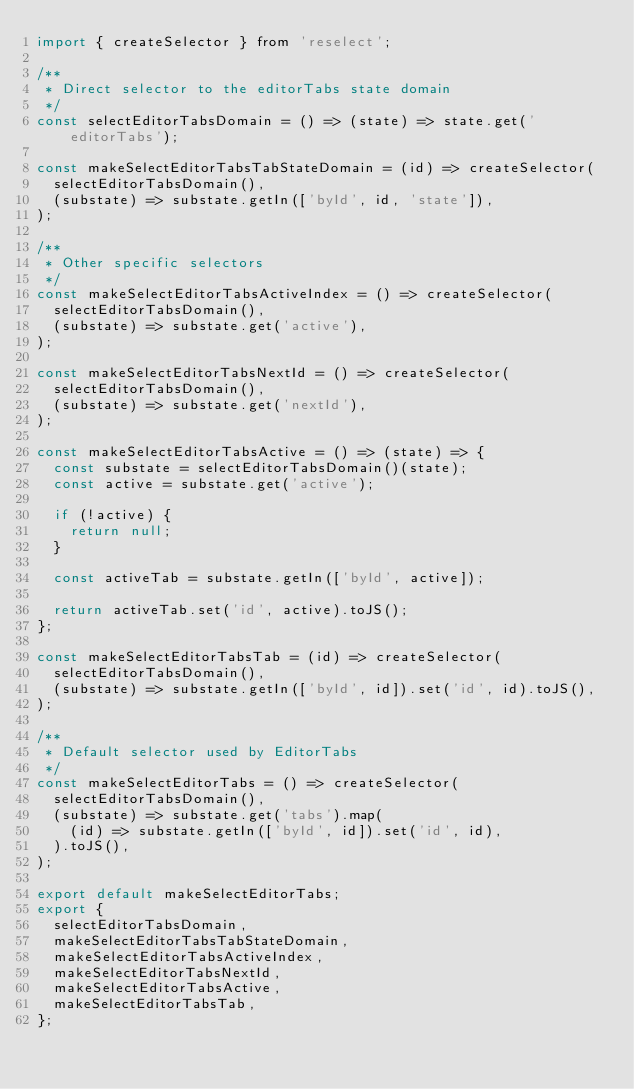<code> <loc_0><loc_0><loc_500><loc_500><_JavaScript_>import { createSelector } from 'reselect';

/**
 * Direct selector to the editorTabs state domain
 */
const selectEditorTabsDomain = () => (state) => state.get('editorTabs');

const makeSelectEditorTabsTabStateDomain = (id) => createSelector(
  selectEditorTabsDomain(),
  (substate) => substate.getIn(['byId', id, 'state']),
);

/**
 * Other specific selectors
 */
const makeSelectEditorTabsActiveIndex = () => createSelector(
  selectEditorTabsDomain(),
  (substate) => substate.get('active'),
);

const makeSelectEditorTabsNextId = () => createSelector(
  selectEditorTabsDomain(),
  (substate) => substate.get('nextId'),
);

const makeSelectEditorTabsActive = () => (state) => {
  const substate = selectEditorTabsDomain()(state);
  const active = substate.get('active');

  if (!active) {
    return null;
  }

  const activeTab = substate.getIn(['byId', active]);

  return activeTab.set('id', active).toJS();
};

const makeSelectEditorTabsTab = (id) => createSelector(
  selectEditorTabsDomain(),
  (substate) => substate.getIn(['byId', id]).set('id', id).toJS(),
);

/**
 * Default selector used by EditorTabs
 */
const makeSelectEditorTabs = () => createSelector(
  selectEditorTabsDomain(),
  (substate) => substate.get('tabs').map(
    (id) => substate.getIn(['byId', id]).set('id', id),
  ).toJS(),
);

export default makeSelectEditorTabs;
export {
  selectEditorTabsDomain,
  makeSelectEditorTabsTabStateDomain,
  makeSelectEditorTabsActiveIndex,
  makeSelectEditorTabsNextId,
  makeSelectEditorTabsActive,
  makeSelectEditorTabsTab,
};
</code> 